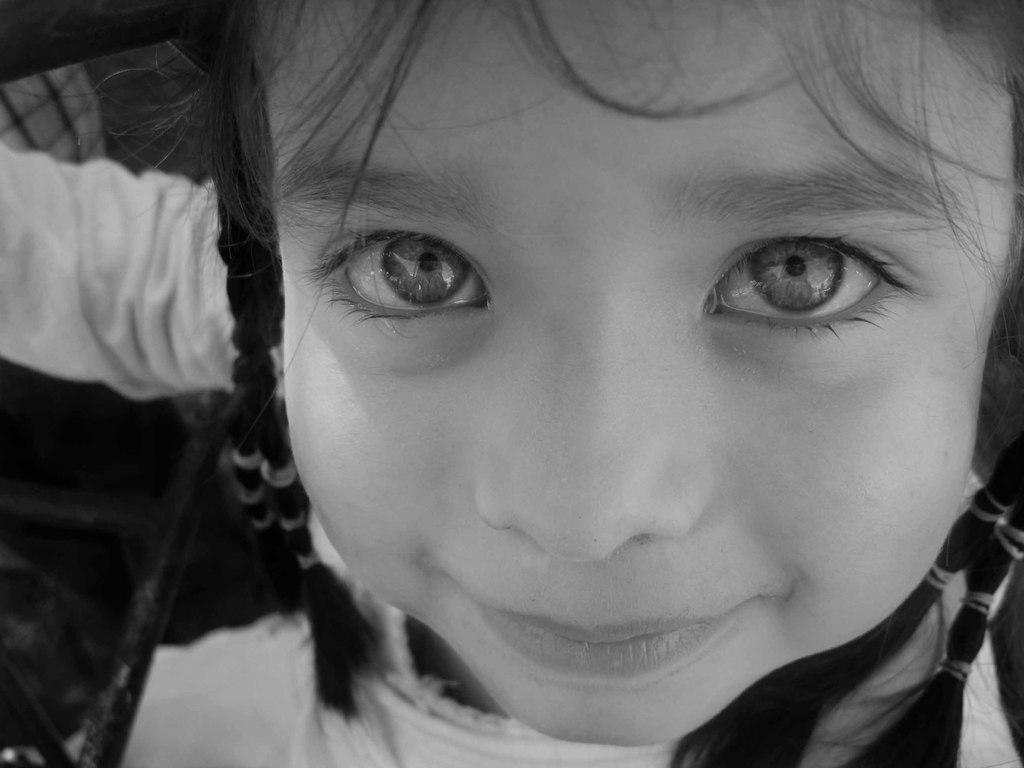Who is the main subject in the image? There is a girl in the center of the image. What type of treatment is the girl receiving in the image? There is no indication in the image that the girl is receiving any treatment, as the provided fact only mentions her presence in the image. 